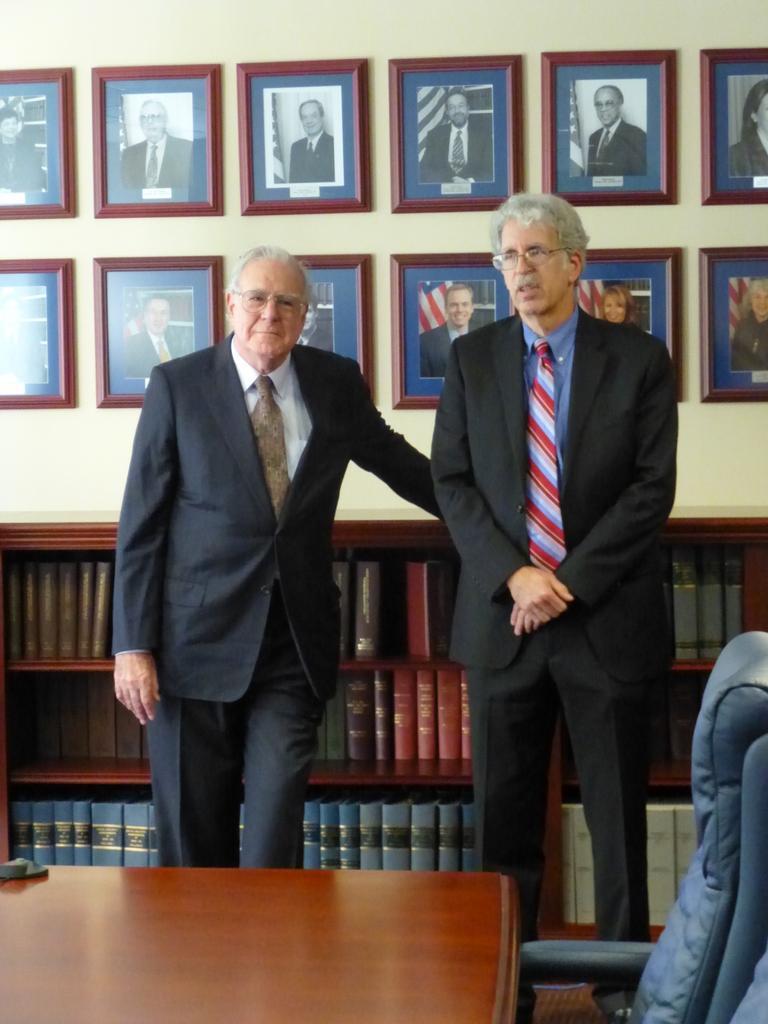In one or two sentences, can you explain what this image depicts? We can see photo frames over a wall. We can standing near to the table. They both wore spectacles. This is a chair. Behind to these two men we can see a cupboard where books are arranged. 